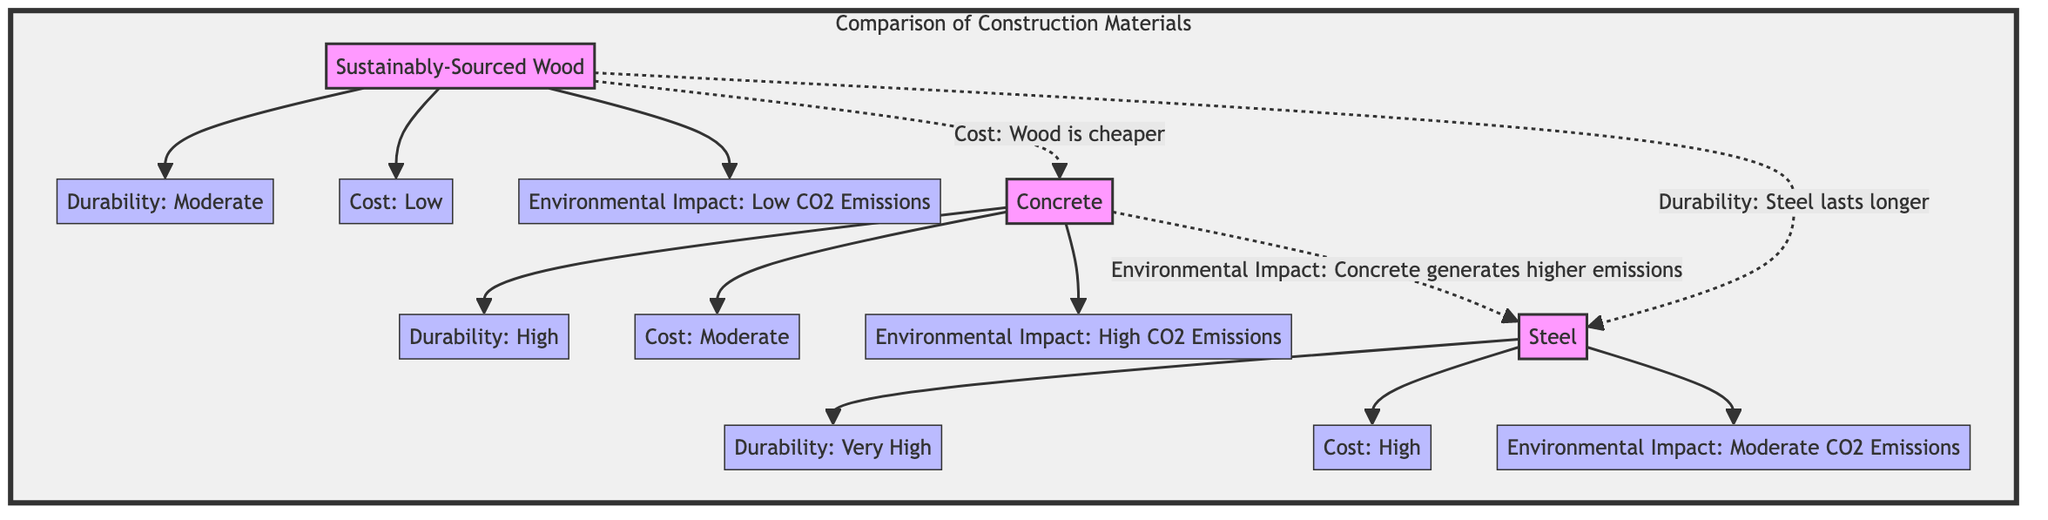What are the durability levels of each construction material? The diagram lists the durability of the materials as follows: Wood has "Moderate" durability, Concrete has "High" durability, and Steel has "Very High" durability.
Answer: Moderate, High, Very High Which material has the lowest cost? According to the diagram, "Sustainably-Sourced Wood" is indicated to have a "Low" cost, making it the cheapest among the materials.
Answer: Low What is the environmental impact of Concrete? The diagram explicitly states that the environmental impact of Concrete involves "High CO2 Emissions."
Answer: High CO2 Emissions How does the cost of Wood compare to Concrete? The diagram indicates that Wood is cheaper when compared to Concrete, as expressed in the dashed relationship stating "Cost: Wood is cheaper."
Answer: Cheaper Which material has a very high environmental impact? Through analyzing the relationships, it is derived that Steel has a "Moderate CO2 Emissions"; however, Concrete has "High CO2 Emissions," leading to the conclusion that Concrete has the very high impact among the materials shown.
Answer: Concrete What is the connection between Wood and Steel in terms of durability? The diagram uses a dashed relationship to imply a comparison, stating "Durability: Steel lasts longer," which directly ties Wood to a lesser durability compared to Steel.
Answer: Steel lasts longer How many total materials are compared in the diagram? By counting the materials listed in the diagram, there are three: Wood, Concrete, and Steel, which makes the total count three.
Answer: Three What is the durability of Wood? As shown in the diagram, the description next to Wood identifies its durability level as "Moderate."
Answer: Moderate 